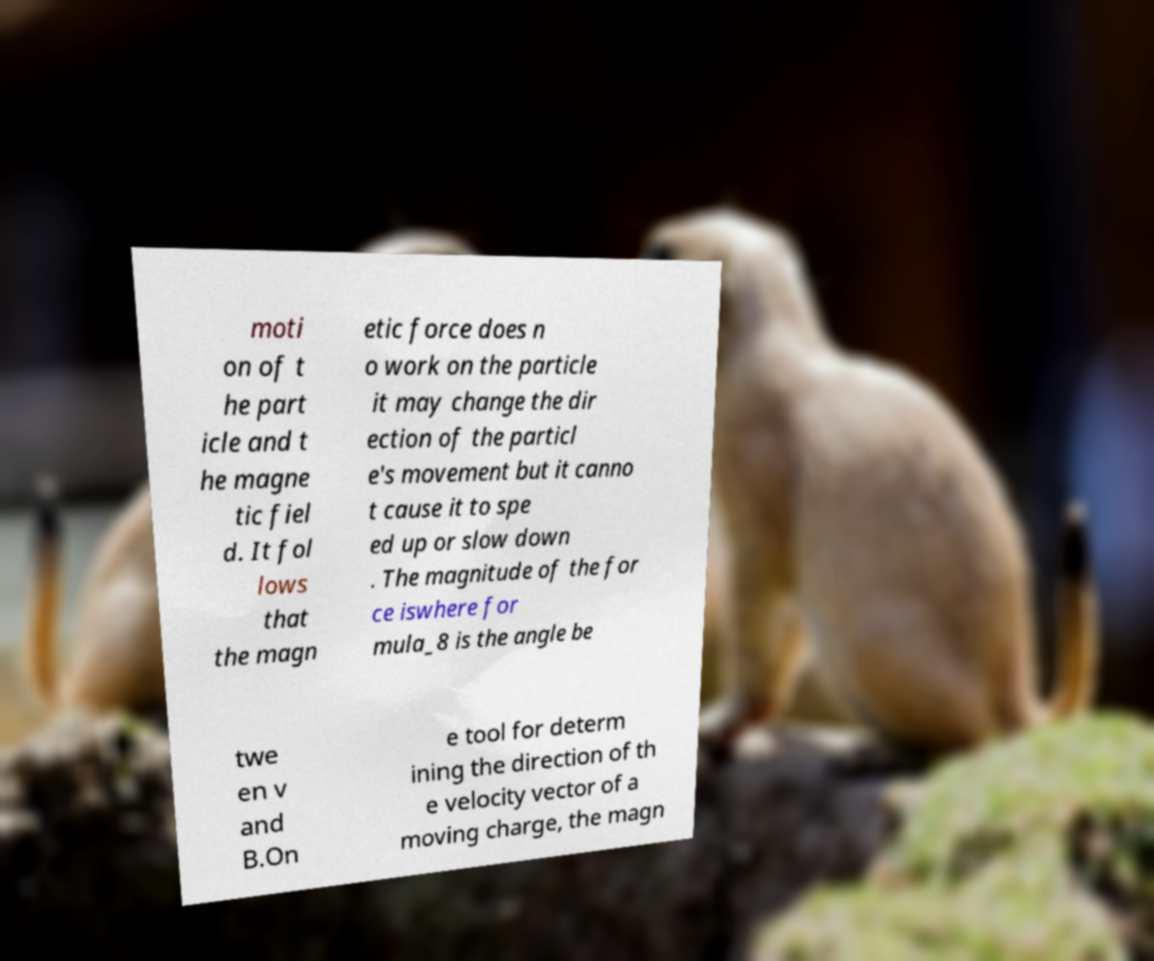Could you assist in decoding the text presented in this image and type it out clearly? moti on of t he part icle and t he magne tic fiel d. It fol lows that the magn etic force does n o work on the particle it may change the dir ection of the particl e's movement but it canno t cause it to spe ed up or slow down . The magnitude of the for ce iswhere for mula_8 is the angle be twe en v and B.On e tool for determ ining the direction of th e velocity vector of a moving charge, the magn 